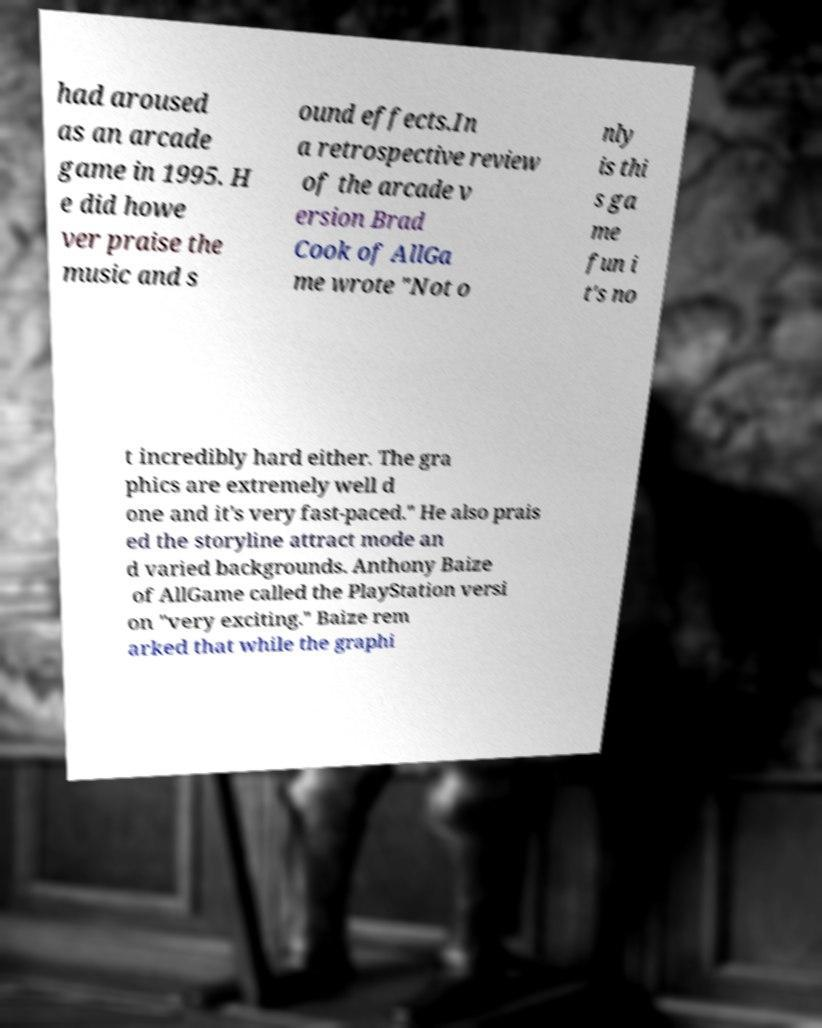For documentation purposes, I need the text within this image transcribed. Could you provide that? had aroused as an arcade game in 1995. H e did howe ver praise the music and s ound effects.In a retrospective review of the arcade v ersion Brad Cook of AllGa me wrote "Not o nly is thi s ga me fun i t's no t incredibly hard either. The gra phics are extremely well d one and it's very fast-paced." He also prais ed the storyline attract mode an d varied backgrounds. Anthony Baize of AllGame called the PlayStation versi on "very exciting." Baize rem arked that while the graphi 